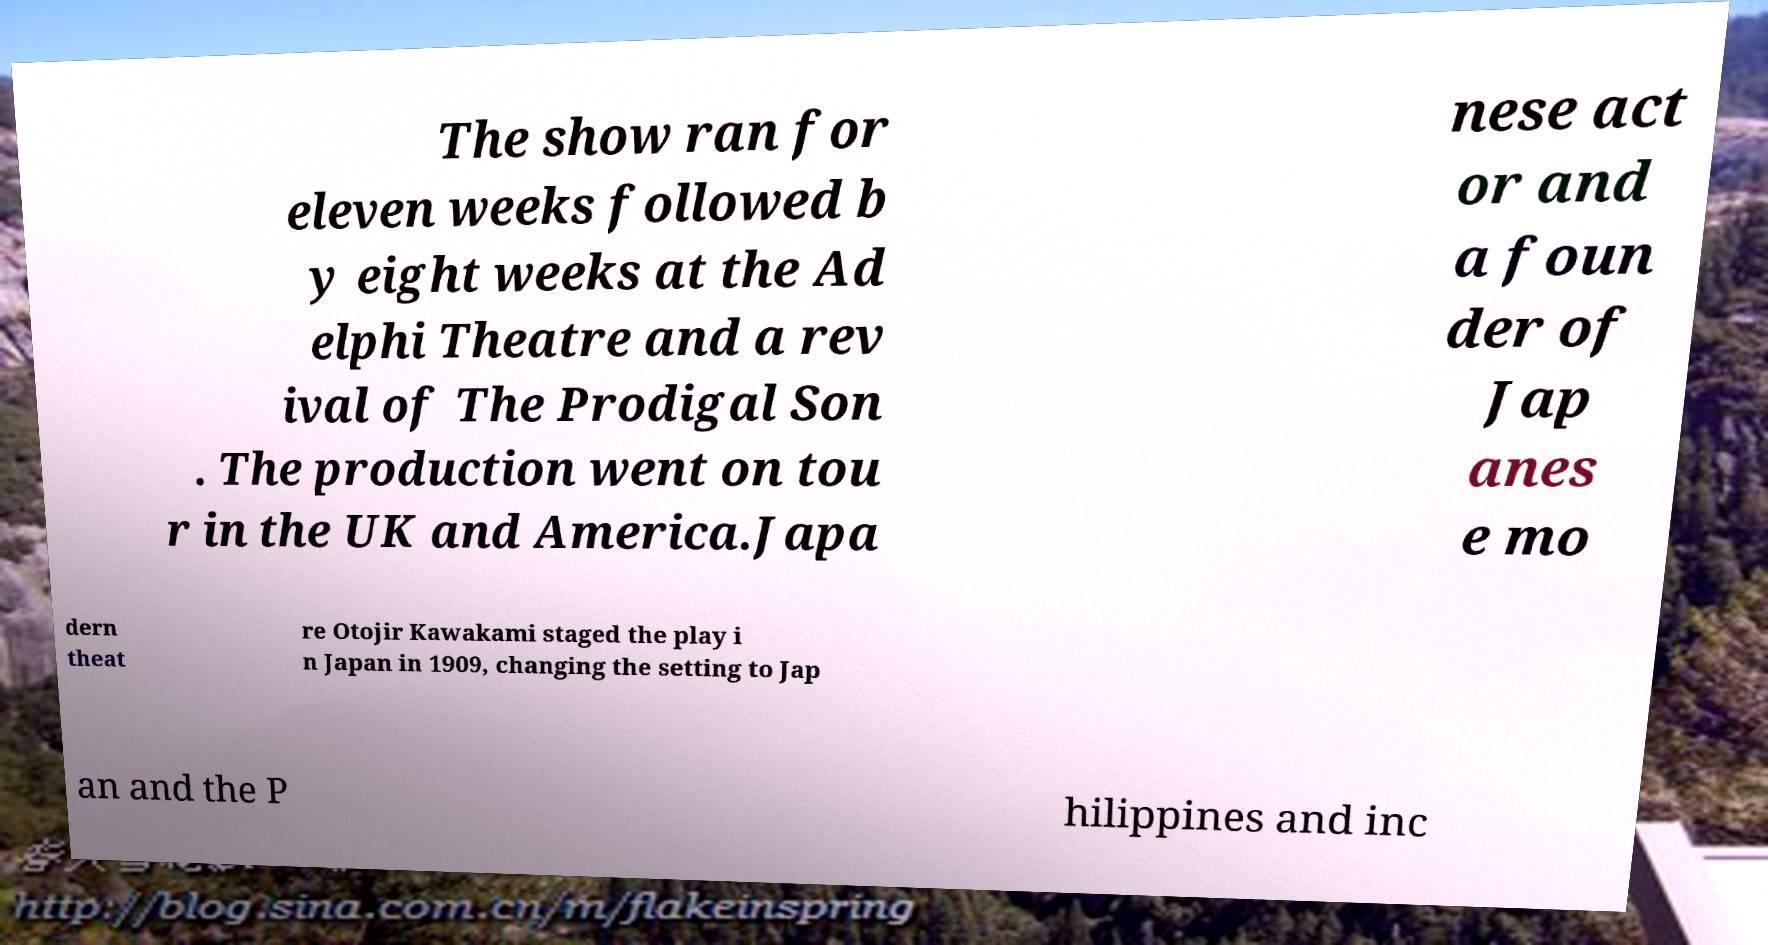Can you read and provide the text displayed in the image?This photo seems to have some interesting text. Can you extract and type it out for me? The show ran for eleven weeks followed b y eight weeks at the Ad elphi Theatre and a rev ival of The Prodigal Son . The production went on tou r in the UK and America.Japa nese act or and a foun der of Jap anes e mo dern theat re Otojir Kawakami staged the play i n Japan in 1909, changing the setting to Jap an and the P hilippines and inc 